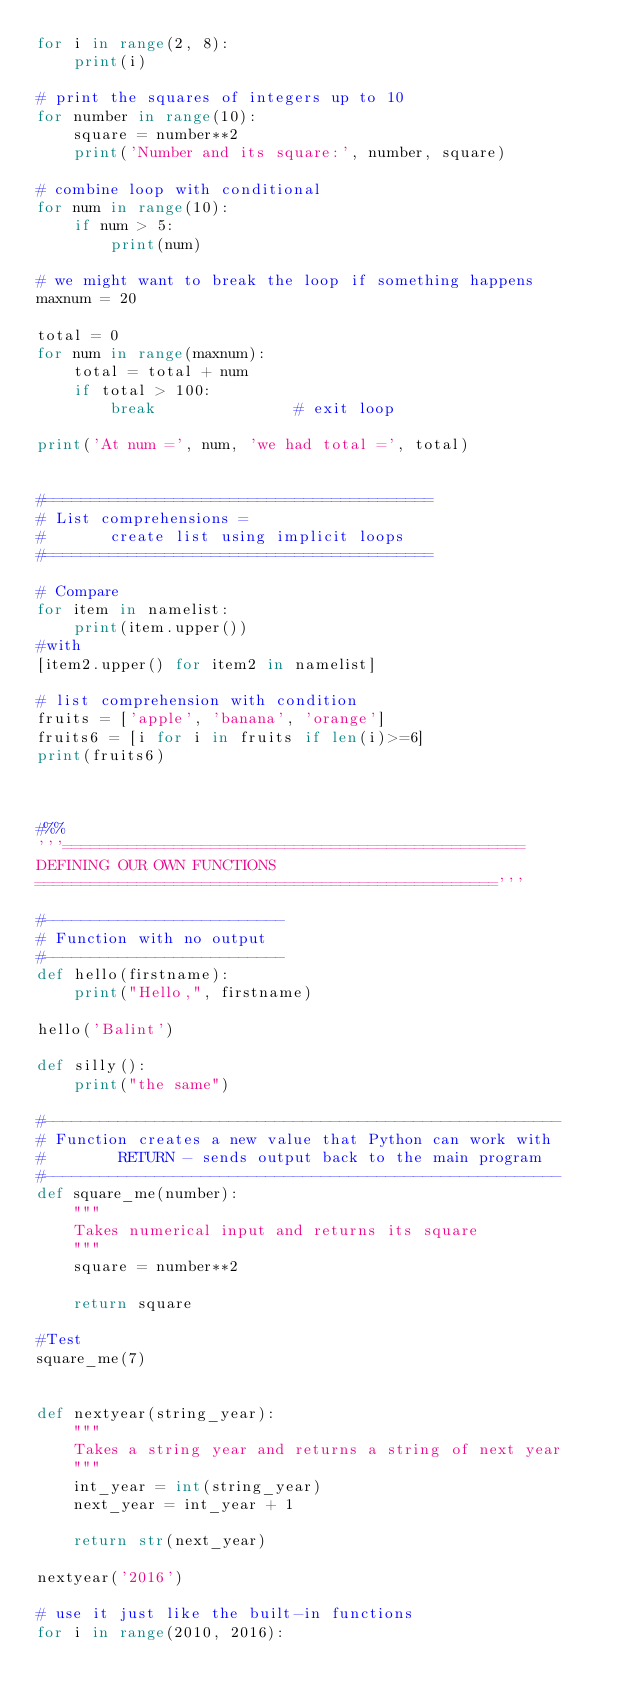Convert code to text. <code><loc_0><loc_0><loc_500><loc_500><_Python_>for i in range(2, 8):
    print(i)

# print the squares of integers up to 10
for number in range(10):
    square = number**2
    print('Number and its square:', number, square)
    
# combine loop with conditional
for num in range(10):
    if num > 5:
        print(num)

# we might want to break the loop if something happens
maxnum = 20

total = 0
for num in range(maxnum):
    total = total + num
    if total > 100:
        break               # exit loop
        
print('At num =', num, 'we had total =', total)


#==========================================
# List comprehensions = 
#       create list using implicit loops
#==========================================

# Compare
for item in namelist:
    print(item.upper())
#with
[item2.upper() for item2 in namelist]    
    
# list comprehension with condition
fruits = ['apple', 'banana', 'orange']
fruits6 = [i for i in fruits if len(i)>=6]
print(fruits6)



#%%
'''==================================================
DEFINING OUR OWN FUNCTIONS
=================================================='''

#--------------------------
# Function with no output
#--------------------------
def hello(firstname):
    print("Hello,", firstname)

hello('Balint')

def silly():
    print("the same")
    
#--------------------------------------------------------
# Function creates a new value that Python can work with
#        RETURN - sends output back to the main program
#--------------------------------------------------------
def square_me(number):
    """
    Takes numerical input and returns its square
    """
    square = number**2
    
    return square

#Test
square_me(7)


def nextyear(string_year):
    """
    Takes a string year and returns a string of next year
    """
    int_year = int(string_year)
    next_year = int_year + 1
    
    return str(next_year)

nextyear('2016')

# use it just like the built-in functions
for i in range(2010, 2016):</code> 